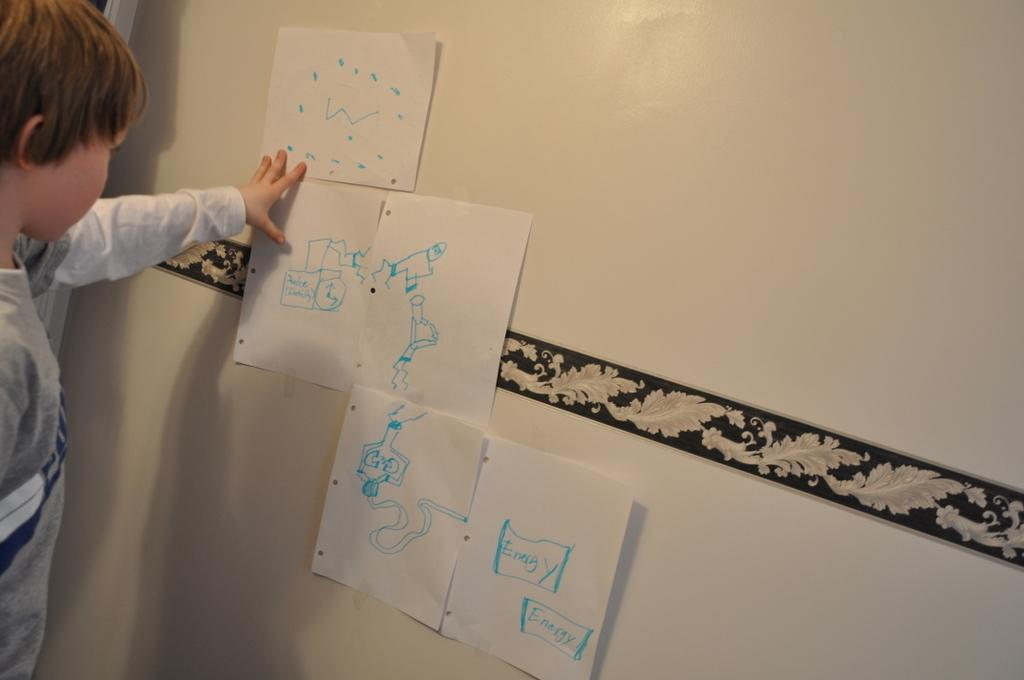<image>
Offer a succinct explanation of the picture presented. A child looks at drawings on a series of papers that are about energy. 